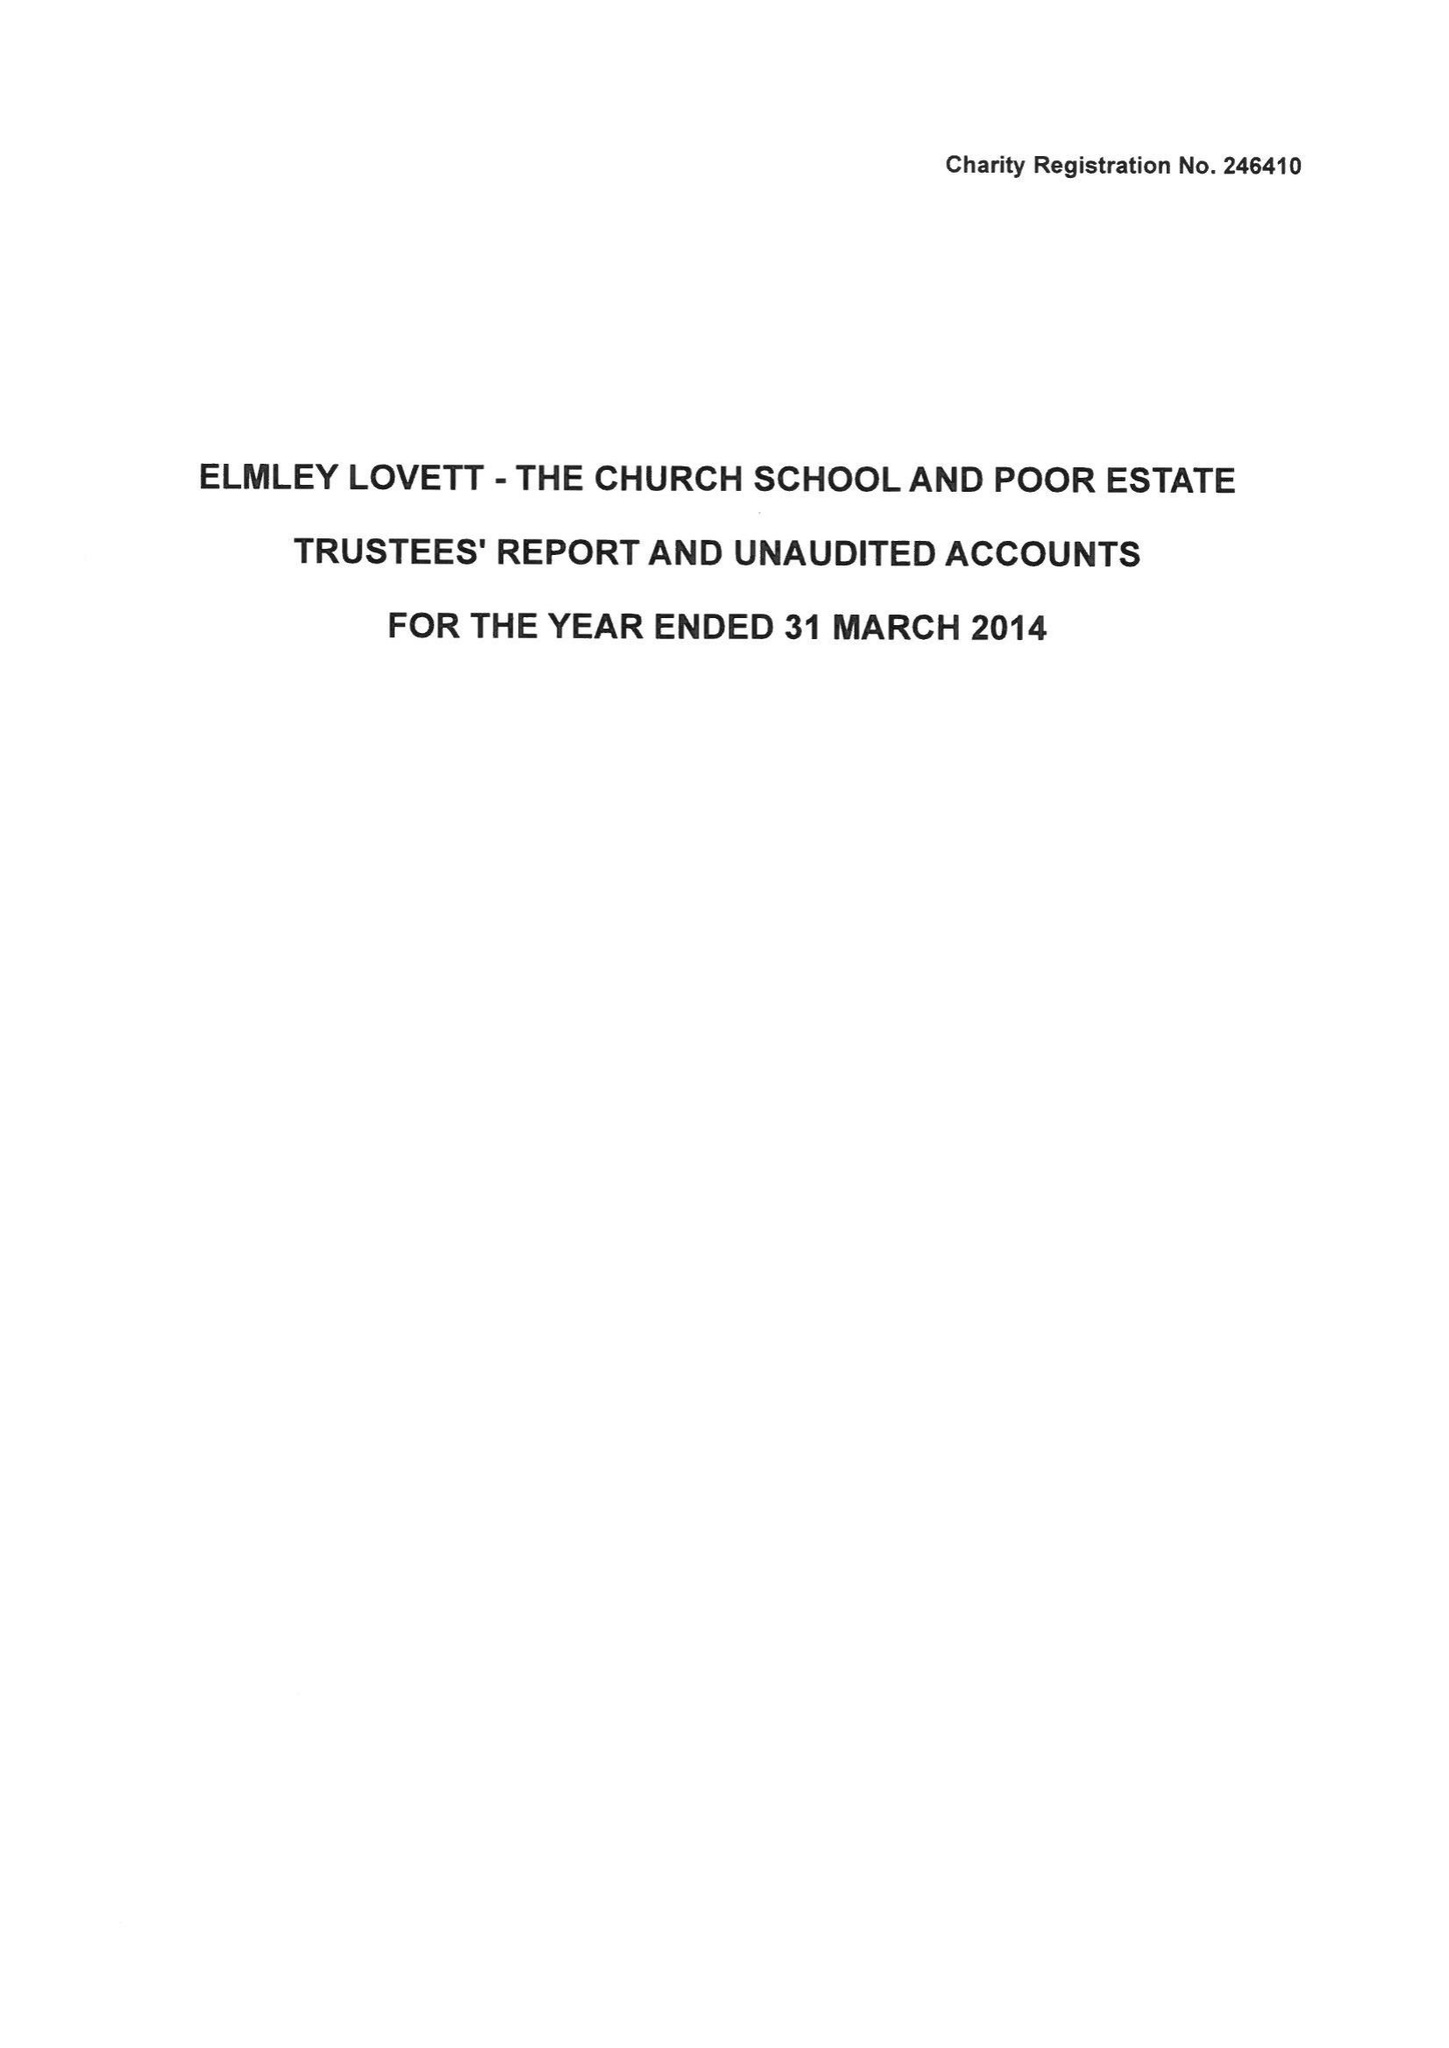What is the value for the charity_name?
Answer the question using a single word or phrase. Elmley Lovett Church, School and Community Trust 